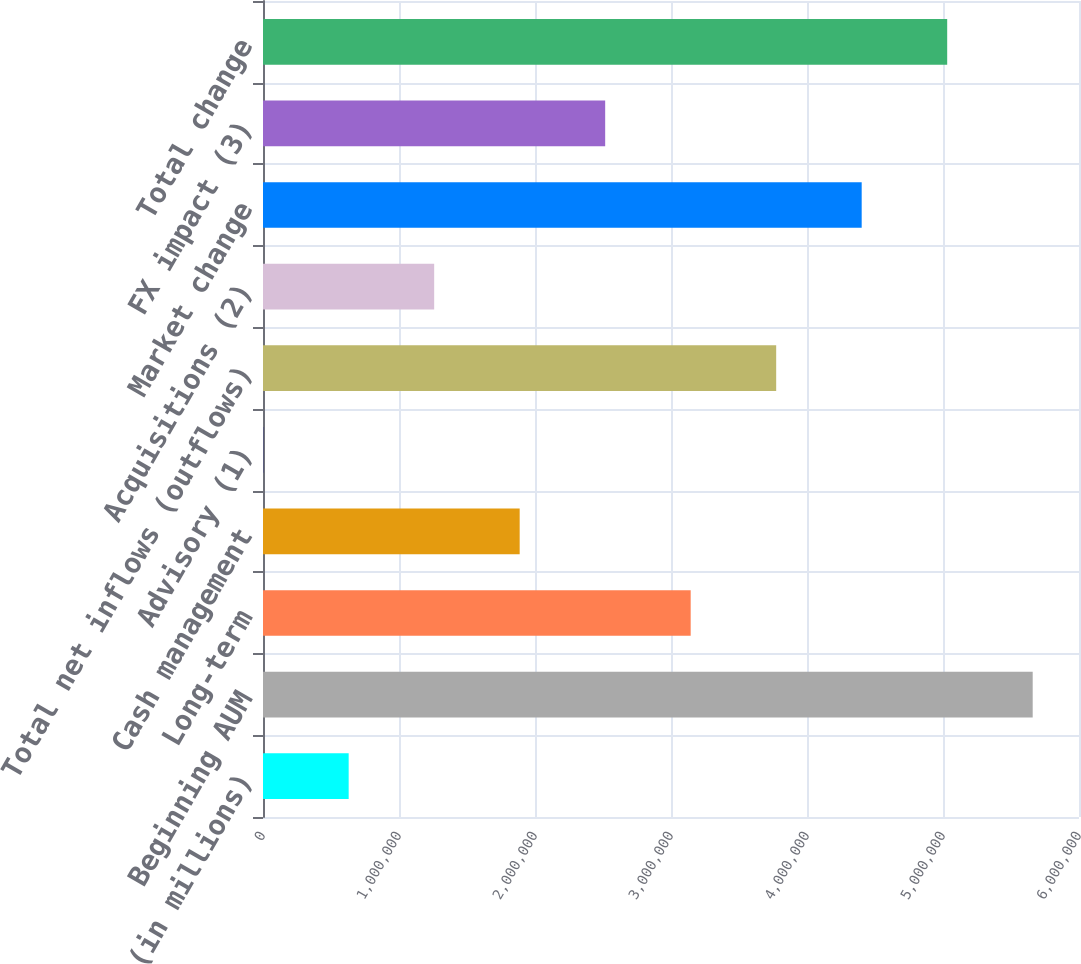<chart> <loc_0><loc_0><loc_500><loc_500><bar_chart><fcel>(in millions)<fcel>Beginning AUM<fcel>Long-term<fcel>Cash management<fcel>Advisory (1)<fcel>Total net inflows (outflows)<fcel>Acquisitions (2)<fcel>Market change<fcel>FX impact (3)<fcel>Total change<nl><fcel>629940<fcel>5.6595e+06<fcel>3.14472e+06<fcel>1.88733e+06<fcel>1245<fcel>3.77342e+06<fcel>1.25864e+06<fcel>4.40211e+06<fcel>2.51602e+06<fcel>5.0308e+06<nl></chart> 